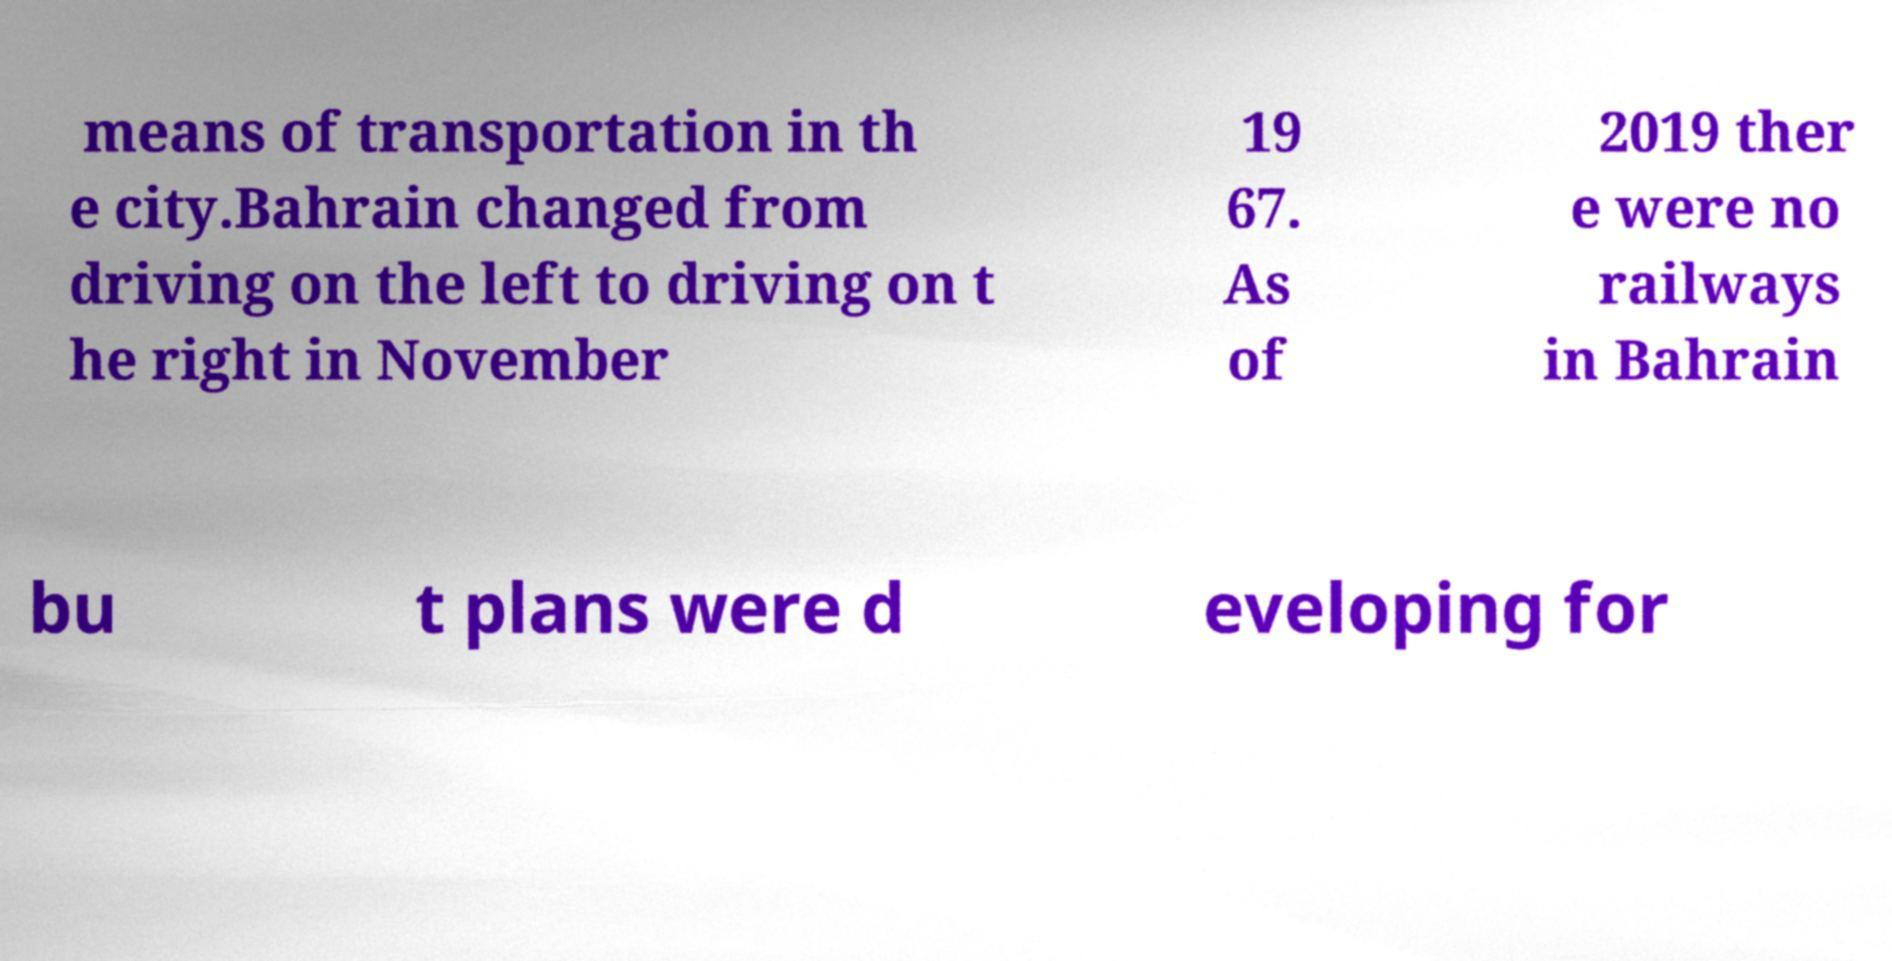Please identify and transcribe the text found in this image. means of transportation in th e city.Bahrain changed from driving on the left to driving on t he right in November 19 67. As of 2019 ther e were no railways in Bahrain bu t plans were d eveloping for 